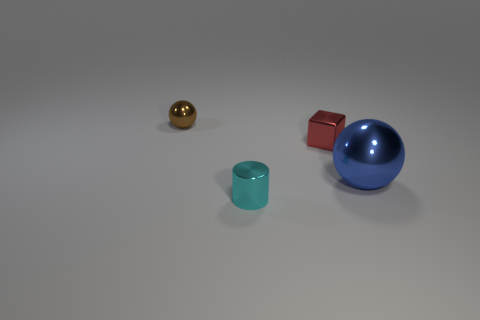How many balls have the same material as the tiny red thing?
Provide a succinct answer. 2. The brown object that is the same shape as the blue thing is what size?
Make the answer very short. Small. Is the shape of the shiny thing on the left side of the small cyan thing the same as  the cyan thing?
Your response must be concise. No. What shape is the object that is on the left side of the tiny metallic object that is in front of the tiny metallic block?
Provide a succinct answer. Sphere. Is there any other thing that is the same shape as the small red object?
Your answer should be compact. No. The tiny metal object that is the same shape as the large blue thing is what color?
Your answer should be compact. Brown. There is a small object that is both left of the red metallic object and in front of the brown object; what is its shape?
Your answer should be compact. Cylinder. Are there fewer red metal things than spheres?
Provide a succinct answer. Yes. Are there any big blue metal objects?
Your response must be concise. Yes. What number of other objects are the same size as the cube?
Ensure brevity in your answer.  2. 